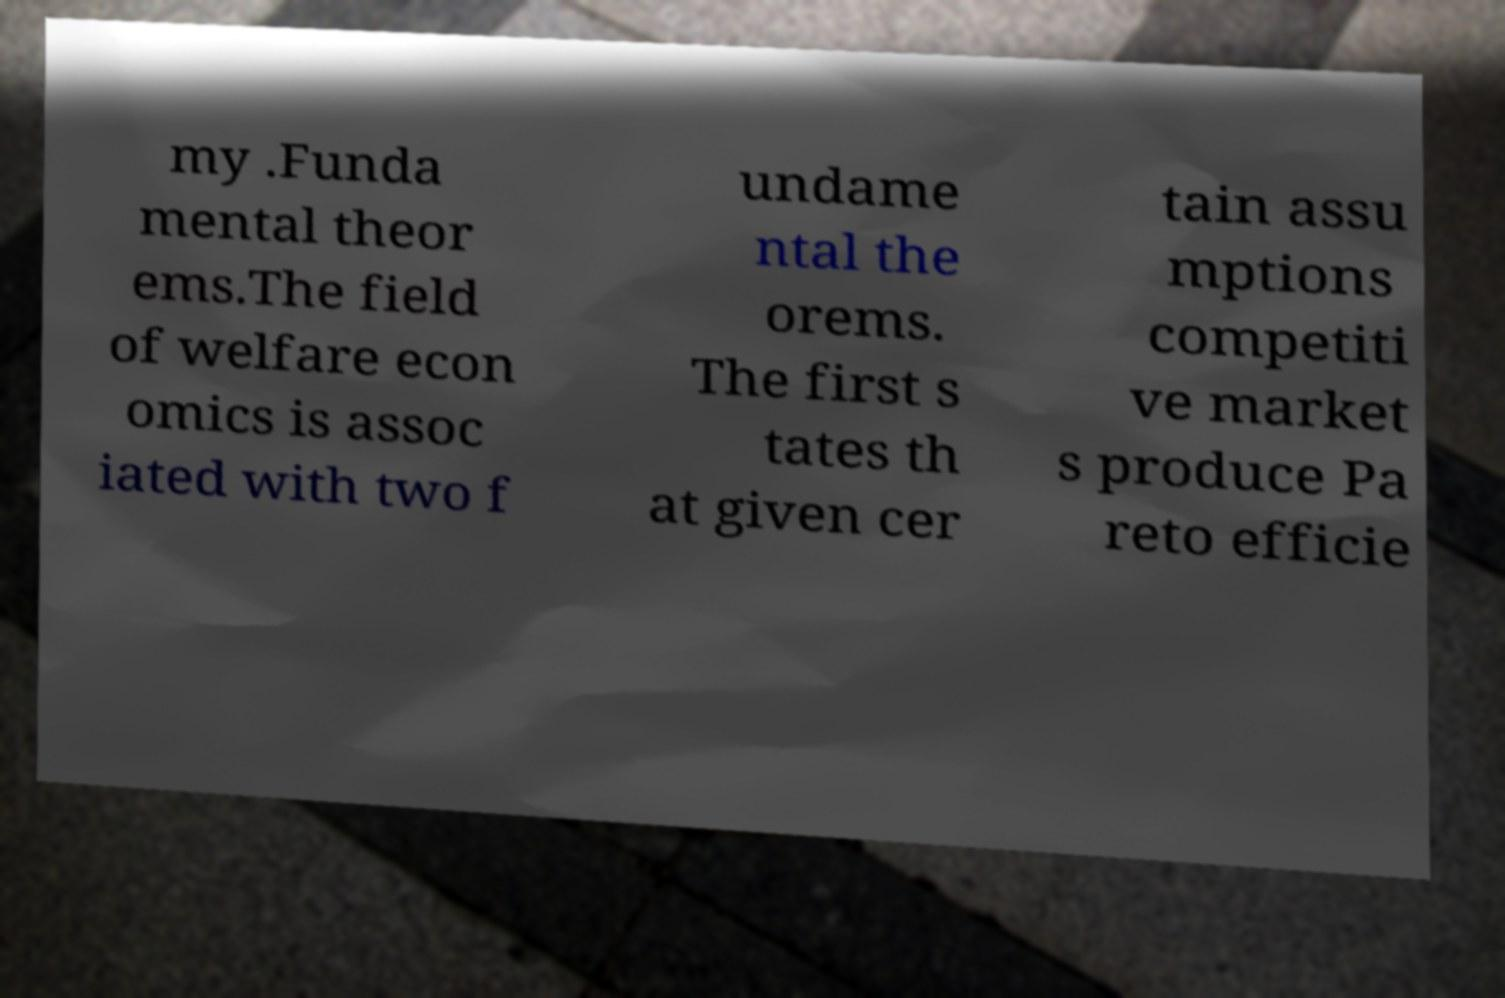For documentation purposes, I need the text within this image transcribed. Could you provide that? my .Funda mental theor ems.The field of welfare econ omics is assoc iated with two f undame ntal the orems. The first s tates th at given cer tain assu mptions competiti ve market s produce Pa reto efficie 